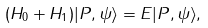<formula> <loc_0><loc_0><loc_500><loc_500>( H _ { 0 } + H _ { 1 } ) | { P } , \psi \rangle = E | { P } , \psi \rangle ,</formula> 